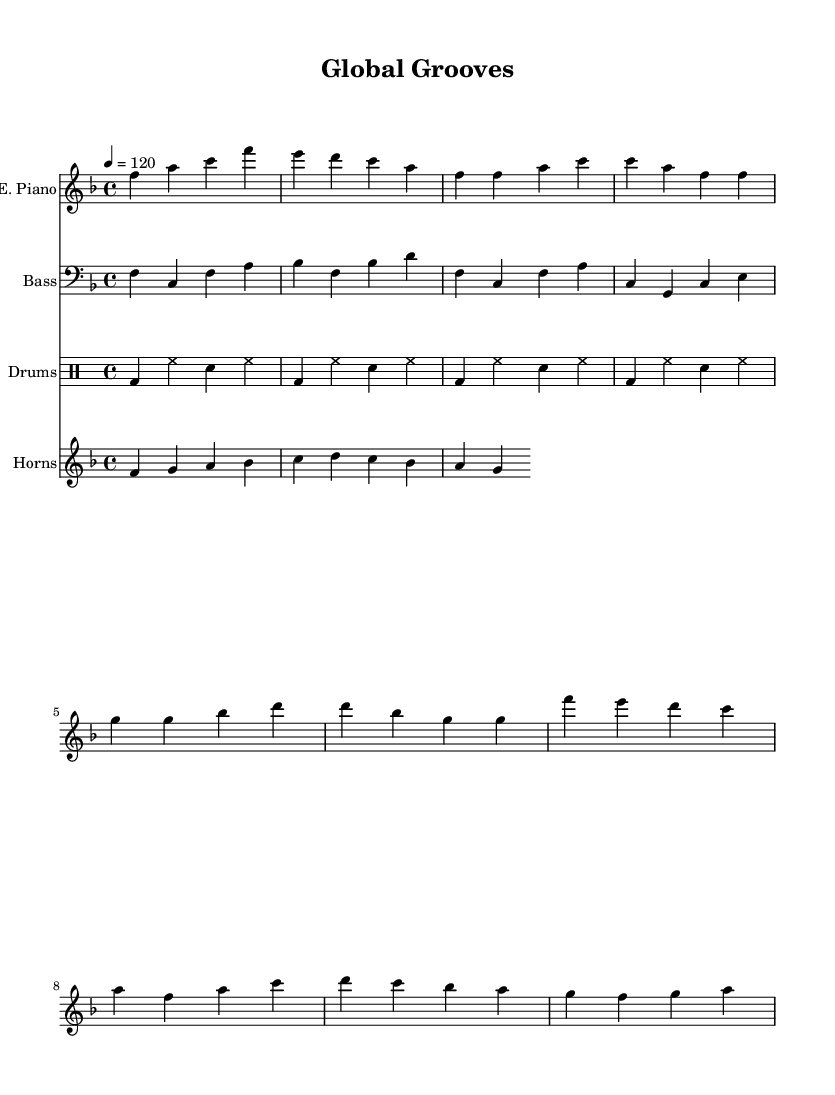What is the key signature of this music? The key signature indicated in the music is F major, which has one flat (B flat). This is deduced by looking at the key signature notation at the beginning of the staff.
Answer: F major What is the time signature of this music? The time signature is 4/4. This can be identified by the fraction shown near the beginning of the score, indicating four beats per measure with a quarter note receiving one beat.
Answer: 4/4 What is the tempo marking in beats per minute? The tempo marking is indicated as 120 beats per minute, which is shown at the beginning of the score with "4 = 120". This tells us how fast the music should be played.
Answer: 120 How many measures are in the electric piano part? The electric piano part consists of 8 measures. By counting the group of vertical lines separating the beats and notes in the electric piano notation, we can determine the number of measures present.
Answer: 8 What instrument has the clef shown in treble? The instrument with the treble clef is the electric piano. The treble clef notation identifies the staff for higher-pitched instruments, which is where the electric piano part is written.
Answer: Electric Piano Does the bass guitar part have any rests? There are no rests in the bass guitar part. By examining the notes in the bass guitar staff closely, we can see that all the beats are filled with notes, indicating continuous sound without breaks.
Answer: No What music style does this piece represent? This piece represents the soul genre, characterized by funky grooves and a focus on rhythms and melodies that convey themes of international travel and cultural exchange. This classification can be inferred from the overall composition style and markings.
Answer: Soul 